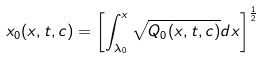Convert formula to latex. <formula><loc_0><loc_0><loc_500><loc_500>x _ { 0 } ( x , t , c ) = \left [ \int _ { \lambda _ { 0 } } ^ { x } \sqrt { Q _ { 0 } ( x , t , c ) } d x \right ] ^ { \frac { 1 } { 2 } }</formula> 